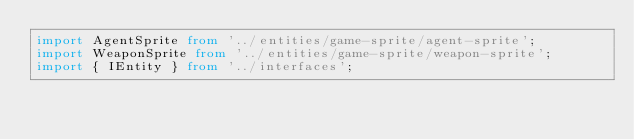<code> <loc_0><loc_0><loc_500><loc_500><_TypeScript_>import AgentSprite from '../entities/game-sprite/agent-sprite';
import WeaponSprite from '../entities/game-sprite/weapon-sprite';
import { IEntity } from '../interfaces';</code> 